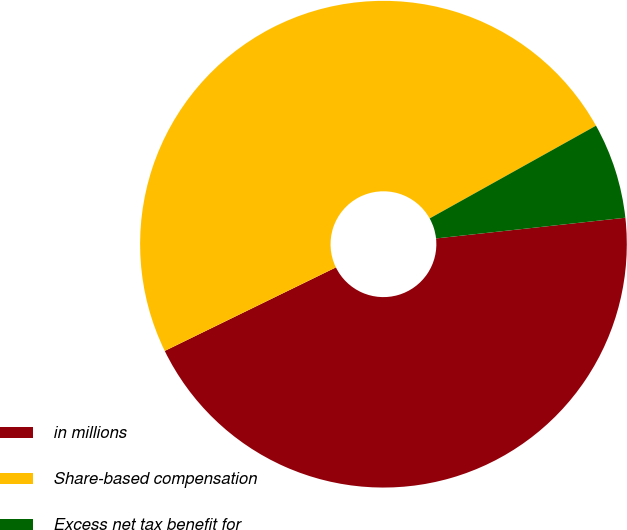Convert chart. <chart><loc_0><loc_0><loc_500><loc_500><pie_chart><fcel>in millions<fcel>Share-based compensation<fcel>Excess net tax benefit for<nl><fcel>44.51%<fcel>49.13%<fcel>6.36%<nl></chart> 